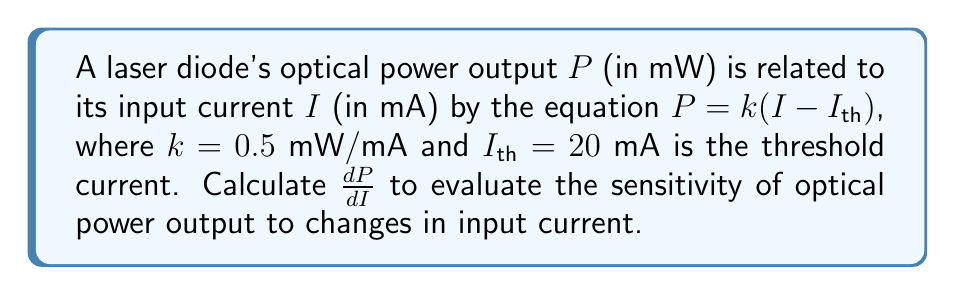Could you help me with this problem? To evaluate the sensitivity of optical power output to changes in input current, we need to find the derivative of $P$ with respect to $I$. Let's follow these steps:

1) We start with the given equation:
   $$P = k(I - I_{th})$$

2) We know that $k = 0.5$ mW/mA and $I_{th} = 20$ mA. However, these are constants, so we don't need to substitute them yet.

3) To find $\frac{dP}{dI}$, we apply the differentiation rules. The equation is in the form of a constant ($k$) multiplied by a linear term $(I - I_{th})$.

4) The derivative of a constant multiplied by a linear term is simply the constant multiplied by the derivative of the linear term:
   $$\frac{d}{dI}[k(I - I_{th})] = k \cdot \frac{d}{dI}(I - I_{th})$$

5) The derivative of $I$ with respect to $I$ is 1, and the derivative of a constant ($I_{th}$) is 0:
   $$k \cdot \frac{d}{dI}(I - I_{th}) = k \cdot (1 - 0) = k$$

6) Therefore, $\frac{dP}{dI} = k = 0.5$ mW/mA

This result shows that for every 1 mA increase in input current, the optical power output increases by 0.5 mW, assuming operation above the threshold current.
Answer: $\frac{dP}{dI} = 0.5$ mW/mA 